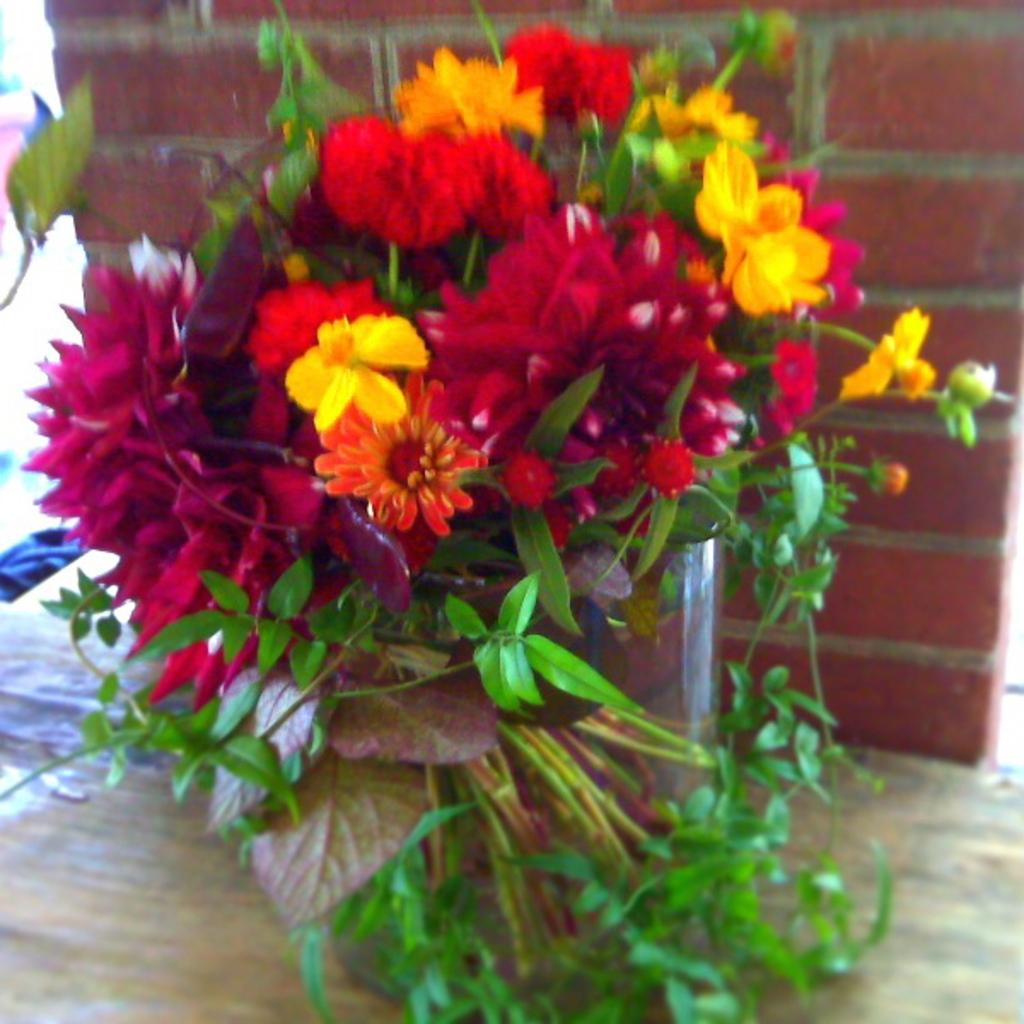What type of plant is visible in the image? There are flowers on a plant in the image. How is the plant contained or displayed? The plant is kept in a pot. What type of background can be seen in the image? There is a brick wall in the image. What direction is the ship sailing in the image? There is no ship present in the image. How does the smoke from the chimney affect the flowers in the image? There is no smoke or chimney present in the image. 